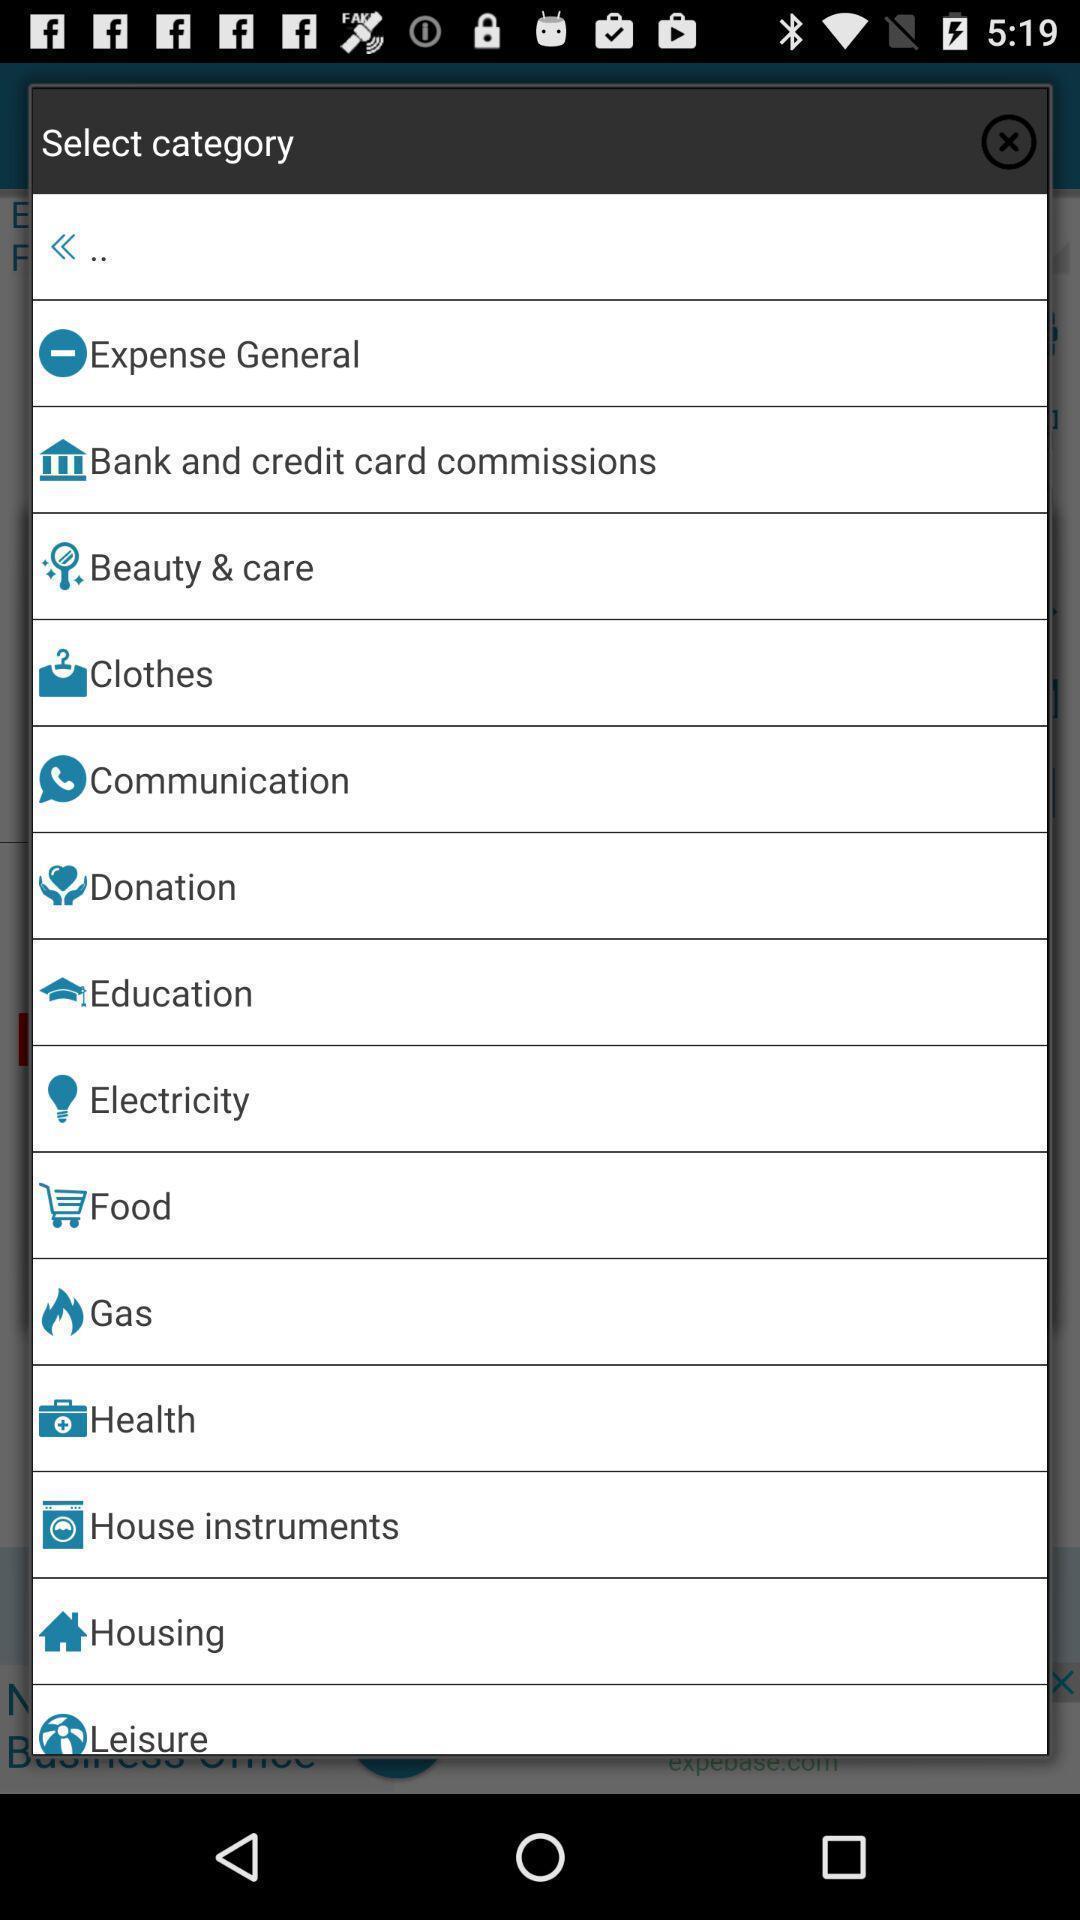Describe this image in words. Screen displaying multiple options to select a category. 